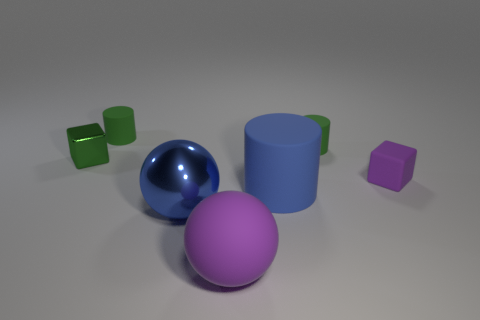Are there any big gray matte things?
Make the answer very short. No. How many other objects are there of the same size as the blue rubber thing?
Give a very brief answer. 2. Are the purple ball and the block that is left of the blue rubber thing made of the same material?
Your answer should be very brief. No. Is the number of shiny objects that are left of the metal sphere the same as the number of big blue rubber things that are right of the small metallic block?
Your response must be concise. Yes. What is the material of the large purple object?
Your response must be concise. Rubber. What is the color of the shiny thing that is the same size as the blue matte cylinder?
Offer a terse response. Blue. Is there a thing left of the tiny green cylinder on the right side of the metallic ball?
Ensure brevity in your answer.  Yes. What number of blocks are large blue things or tiny purple rubber things?
Keep it short and to the point. 1. What is the size of the ball behind the purple rubber object that is in front of the tiny purple rubber object behind the shiny ball?
Ensure brevity in your answer.  Large. There is a small purple rubber cube; are there any objects left of it?
Your response must be concise. Yes. 